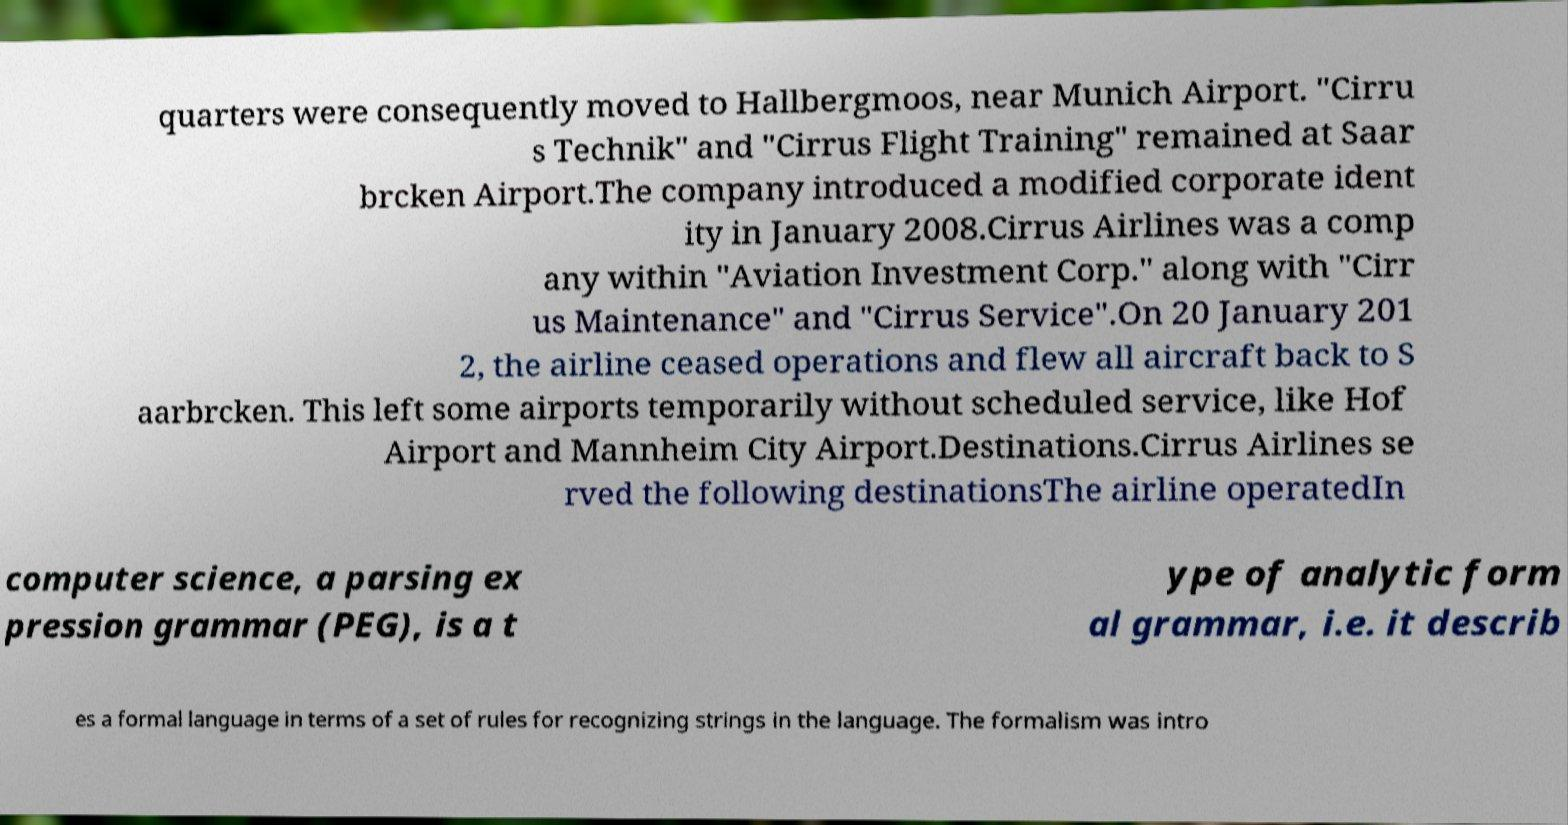Please identify and transcribe the text found in this image. quarters were consequently moved to Hallbergmoos, near Munich Airport. "Cirru s Technik" and "Cirrus Flight Training" remained at Saar brcken Airport.The company introduced a modified corporate ident ity in January 2008.Cirrus Airlines was a comp any within "Aviation Investment Corp." along with "Cirr us Maintenance" and "Cirrus Service".On 20 January 201 2, the airline ceased operations and flew all aircraft back to S aarbrcken. This left some airports temporarily without scheduled service, like Hof Airport and Mannheim City Airport.Destinations.Cirrus Airlines se rved the following destinationsThe airline operatedIn computer science, a parsing ex pression grammar (PEG), is a t ype of analytic form al grammar, i.e. it describ es a formal language in terms of a set of rules for recognizing strings in the language. The formalism was intro 